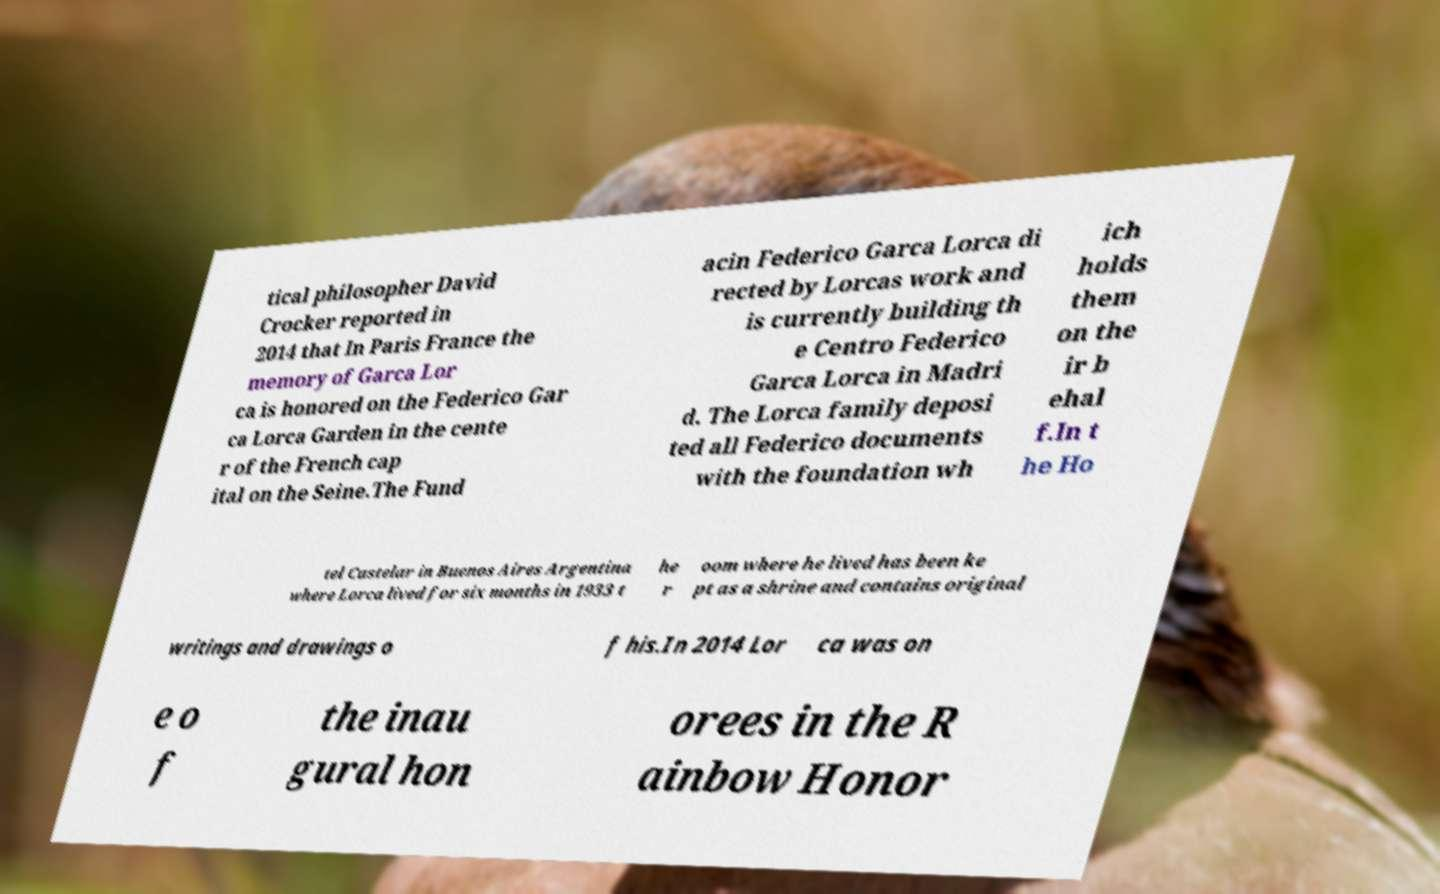What messages or text are displayed in this image? I need them in a readable, typed format. tical philosopher David Crocker reported in 2014 that In Paris France the memory of Garca Lor ca is honored on the Federico Gar ca Lorca Garden in the cente r of the French cap ital on the Seine.The Fund acin Federico Garca Lorca di rected by Lorcas work and is currently building th e Centro Federico Garca Lorca in Madri d. The Lorca family deposi ted all Federico documents with the foundation wh ich holds them on the ir b ehal f.In t he Ho tel Castelar in Buenos Aires Argentina where Lorca lived for six months in 1933 t he r oom where he lived has been ke pt as a shrine and contains original writings and drawings o f his.In 2014 Lor ca was on e o f the inau gural hon orees in the R ainbow Honor 